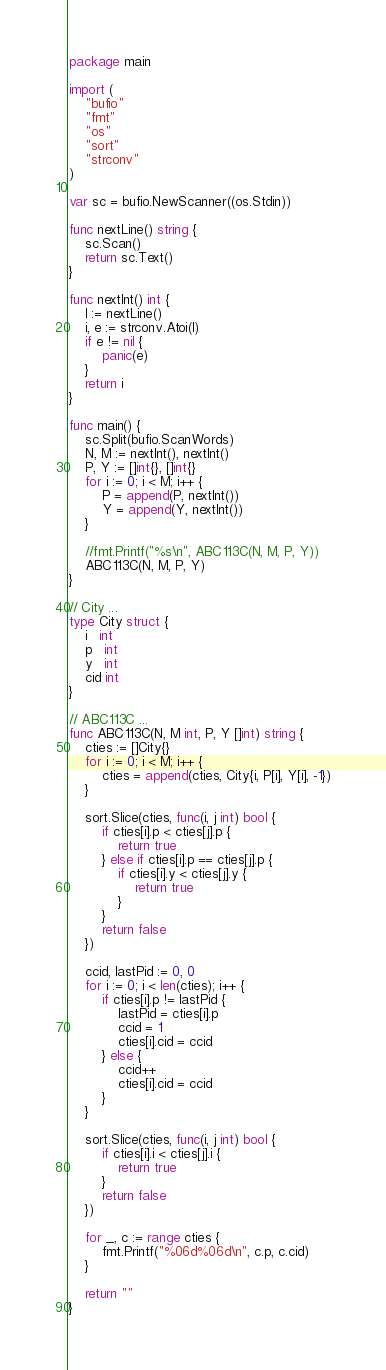Convert code to text. <code><loc_0><loc_0><loc_500><loc_500><_Go_>package main

import (
	"bufio"
	"fmt"
	"os"
	"sort"
	"strconv"
)

var sc = bufio.NewScanner((os.Stdin))

func nextLine() string {
	sc.Scan()
	return sc.Text()
}

func nextInt() int {
	l := nextLine()
	i, e := strconv.Atoi(l)
	if e != nil {
		panic(e)
	}
	return i
}

func main() {
	sc.Split(bufio.ScanWords)
	N, M := nextInt(), nextInt()
	P, Y := []int{}, []int{}
	for i := 0; i < M; i++ {
		P = append(P, nextInt())
		Y = append(Y, nextInt())
	}

	//fmt.Printf("%s\n", ABC113C(N, M, P, Y))
	ABC113C(N, M, P, Y)
}

// City ...
type City struct {
	i   int
	p   int
	y   int
	cid int
}

// ABC113C ...
func ABC113C(N, M int, P, Y []int) string {
	cties := []City{}
	for i := 0; i < M; i++ {
		cties = append(cties, City{i, P[i], Y[i], -1})
	}

	sort.Slice(cties, func(i, j int) bool {
		if cties[i].p < cties[j].p {
			return true
		} else if cties[i].p == cties[j].p {
			if cties[i].y < cties[j].y {
				return true
			}
		}
		return false
	})

	ccid, lastPid := 0, 0
	for i := 0; i < len(cties); i++ {
		if cties[i].p != lastPid {
			lastPid = cties[i].p
			ccid = 1
			cties[i].cid = ccid
		} else {
			ccid++
			cties[i].cid = ccid
		}
	}

	sort.Slice(cties, func(i, j int) bool {
		if cties[i].i < cties[j].i {
			return true
		}
		return false
	})

	for _, c := range cties {
		fmt.Printf("%06d%06d\n", c.p, c.cid)
	}

	return ""
}
</code> 